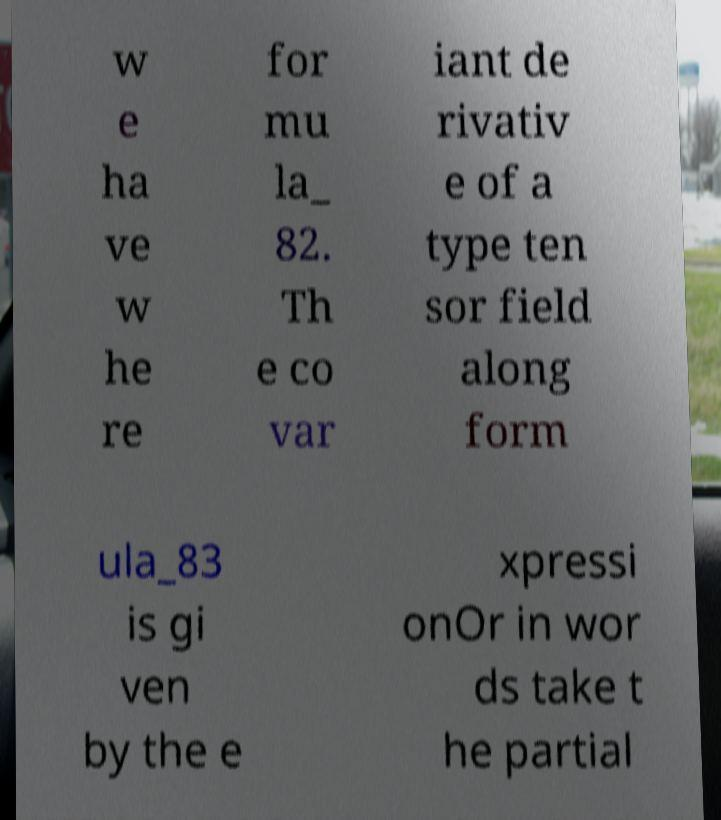There's text embedded in this image that I need extracted. Can you transcribe it verbatim? w e ha ve w he re for mu la_ 82. Th e co var iant de rivativ e of a type ten sor field along form ula_83 is gi ven by the e xpressi onOr in wor ds take t he partial 